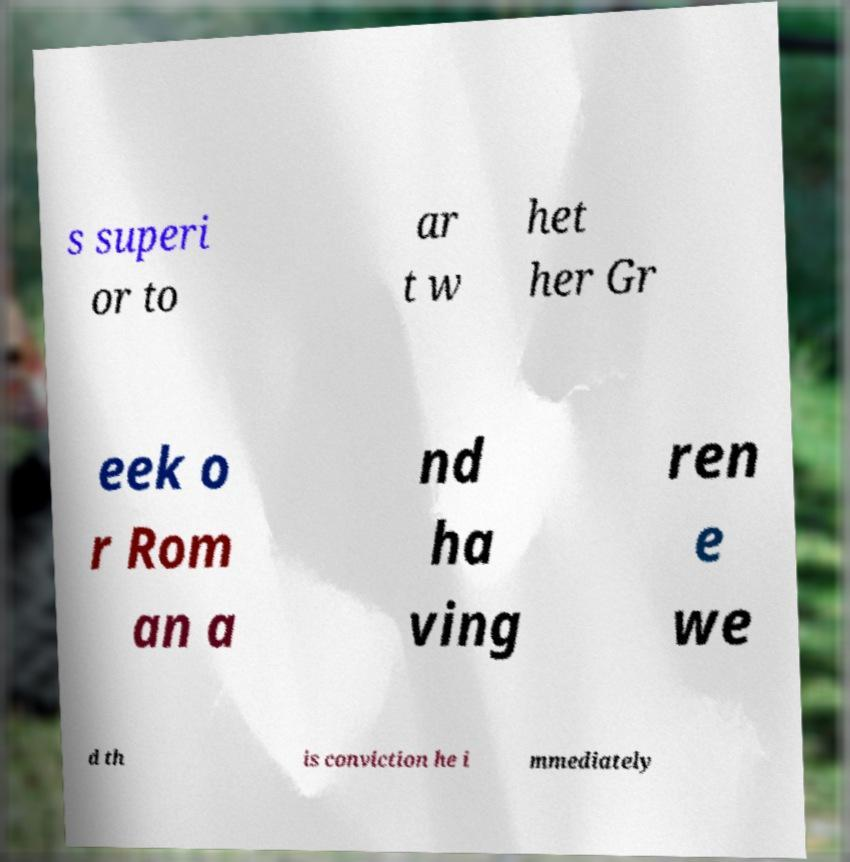Can you read and provide the text displayed in the image?This photo seems to have some interesting text. Can you extract and type it out for me? s superi or to ar t w het her Gr eek o r Rom an a nd ha ving ren e we d th is conviction he i mmediately 